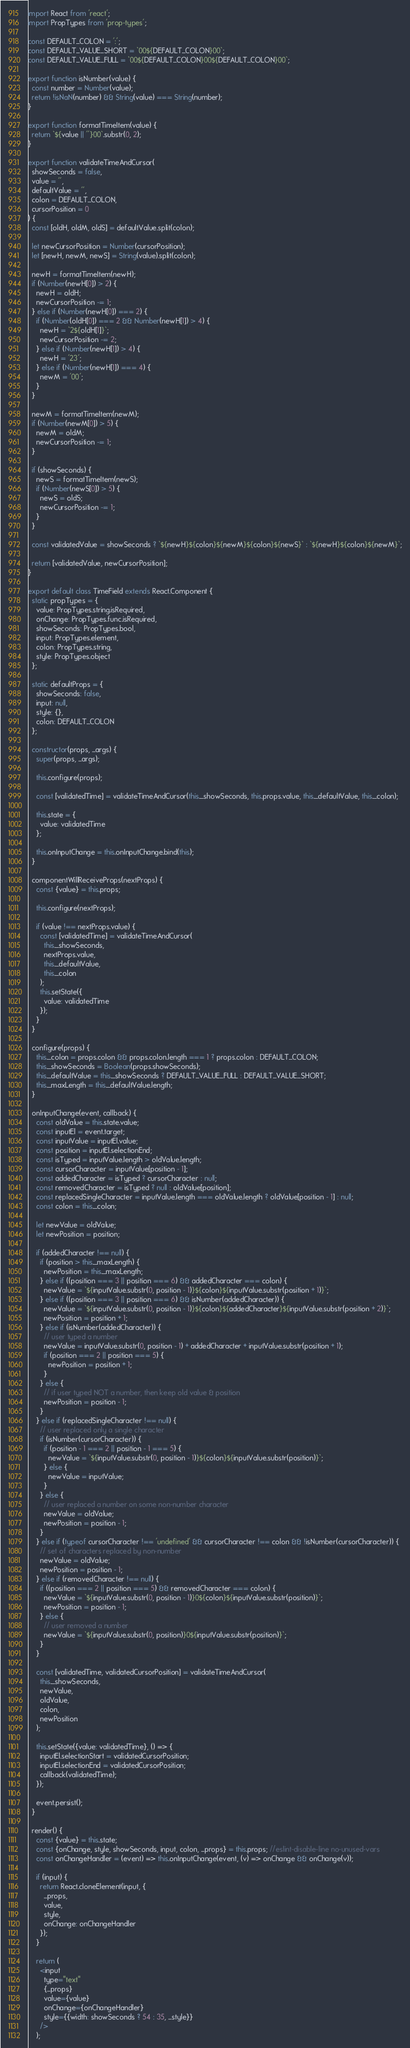Convert code to text. <code><loc_0><loc_0><loc_500><loc_500><_JavaScript_>import React from 'react';
import PropTypes from 'prop-types';

const DEFAULT_COLON = ':';
const DEFAULT_VALUE_SHORT = `00${DEFAULT_COLON}00`;
const DEFAULT_VALUE_FULL = `00${DEFAULT_COLON}00${DEFAULT_COLON}00`;

export function isNumber(value) {
  const number = Number(value);
  return !isNaN(number) && String(value) === String(number);
}

export function formatTimeItem(value) {
  return `${value || ''}00`.substr(0, 2);
}

export function validateTimeAndCursor(
  showSeconds = false,
  value = '',
  defaultValue = '',
  colon = DEFAULT_COLON,
  cursorPosition = 0
) {
  const [oldH, oldM, oldS] = defaultValue.split(colon);

  let newCursorPosition = Number(cursorPosition);
  let [newH, newM, newS] = String(value).split(colon);

  newH = formatTimeItem(newH);
  if (Number(newH[0]) > 2) {
    newH = oldH;
    newCursorPosition -= 1;
  } else if (Number(newH[0]) === 2) {
    if (Number(oldH[0]) === 2 && Number(newH[1]) > 4) {
      newH = `2${oldH[1]}`;
      newCursorPosition -= 2;
    } else if (Number(newH[1]) > 4) {
      newH = '23';
    } else if (Number(newH[1]) === 4) {
      newM = '00';
    }
  }

  newM = formatTimeItem(newM);
  if (Number(newM[0]) > 5) {
    newM = oldM;
    newCursorPosition -= 1;
  }

  if (showSeconds) {
    newS = formatTimeItem(newS);
    if (Number(newS[0]) > 5) {
      newS = oldS;
      newCursorPosition -= 1;
    }
  }

  const validatedValue = showSeconds ? `${newH}${colon}${newM}${colon}${newS}` : `${newH}${colon}${newM}`;

  return [validatedValue, newCursorPosition];
}

export default class TimeField extends React.Component {
  static propTypes = {
    value: PropTypes.string.isRequired,
    onChange: PropTypes.func.isRequired,
    showSeconds: PropTypes.bool,
    input: PropTypes.element,
    colon: PropTypes.string,
    style: PropTypes.object
  };

  static defaultProps = {
    showSeconds: false,
    input: null,
    style: {},
    colon: DEFAULT_COLON
  };

  constructor(props, ...args) {
    super(props, ...args);

    this.configure(props);

    const [validatedTime] = validateTimeAndCursor(this._showSeconds, this.props.value, this._defaultValue, this._colon);

    this.state = {
      value: validatedTime
    };

    this.onInputChange = this.onInputChange.bind(this);
  }

  componentWillReceiveProps(nextProps) {
    const {value} = this.props;

    this.configure(nextProps);

    if (value !== nextProps.value) {
      const [validatedTime] = validateTimeAndCursor(
        this._showSeconds,
        nextProps.value,
        this._defaultValue,
        this._colon
      );
      this.setState({
        value: validatedTime
      });
    }
  }

  configure(props) {
    this._colon = props.colon && props.colon.length === 1 ? props.colon : DEFAULT_COLON;
    this._showSeconds = Boolean(props.showSeconds);
    this._defaultValue = this._showSeconds ? DEFAULT_VALUE_FULL : DEFAULT_VALUE_SHORT;
    this._maxLength = this._defaultValue.length;
  }

  onInputChange(event, callback) {
    const oldValue = this.state.value;
    const inputEl = event.target;
    const inputValue = inputEl.value;
    const position = inputEl.selectionEnd;
    const isTyped = inputValue.length > oldValue.length;
    const cursorCharacter = inputValue[position - 1];
    const addedCharacter = isTyped ? cursorCharacter : null;
    const removedCharacter = isTyped ? null : oldValue[position];
    const replacedSingleCharacter = inputValue.length === oldValue.length ? oldValue[position - 1] : null;
    const colon = this._colon;

    let newValue = oldValue;
    let newPosition = position;

    if (addedCharacter !== null) {
      if (position > this._maxLength) {
        newPosition = this._maxLength;
      } else if ((position === 3 || position === 6) && addedCharacter === colon) {
        newValue = `${inputValue.substr(0, position - 1)}${colon}${inputValue.substr(position + 1)}`;
      } else if ((position === 3 || position === 6) && isNumber(addedCharacter)) {
        newValue = `${inputValue.substr(0, position - 1)}${colon}${addedCharacter}${inputValue.substr(position + 2)}`;
        newPosition = position + 1;
      } else if (isNumber(addedCharacter)) {
        // user typed a number
        newValue = inputValue.substr(0, position - 1) + addedCharacter + inputValue.substr(position + 1);
        if (position === 2 || position === 5) {
          newPosition = position + 1;
        }
      } else {
        // if user typed NOT a number, then keep old value & position
        newPosition = position - 1;
      }
    } else if (replacedSingleCharacter !== null) {
      // user replaced only a single character
      if (isNumber(cursorCharacter)) {
        if (position - 1 === 2 || position - 1 === 5) {
          newValue = `${inputValue.substr(0, position - 1)}${colon}${inputValue.substr(position)}`;
        } else {
          newValue = inputValue;
        }
      } else {
        // user replaced a number on some non-number character
        newValue = oldValue;
        newPosition = position - 1;
      }
    } else if (typeof cursorCharacter !== 'undefined' && cursorCharacter !== colon && !isNumber(cursorCharacter)) {
      // set of characters replaced by non-number
      newValue = oldValue;
      newPosition = position - 1;
    } else if (removedCharacter !== null) {
      if ((position === 2 || position === 5) && removedCharacter === colon) {
        newValue = `${inputValue.substr(0, position - 1)}0${colon}${inputValue.substr(position)}`;
        newPosition = position - 1;
      } else {
        // user removed a number
        newValue = `${inputValue.substr(0, position)}0${inputValue.substr(position)}`;
      }
    }

    const [validatedTime, validatedCursorPosition] = validateTimeAndCursor(
      this._showSeconds,
      newValue,
      oldValue,
      colon,
      newPosition
    );

    this.setState({value: validatedTime}, () => {
      inputEl.selectionStart = validatedCursorPosition;
      inputEl.selectionEnd = validatedCursorPosition;
      callback(validatedTime);
    });

    event.persist();
  }

  render() {
    const {value} = this.state;
    const {onChange, style, showSeconds, input, colon, ...props} = this.props; //eslint-disable-line no-unused-vars
    const onChangeHandler = (event) => this.onInputChange(event, (v) => onChange && onChange(v));

    if (input) {
      return React.cloneElement(input, {
        ...props,
        value,
        style,
        onChange: onChangeHandler
      });
    }

    return (
      <input
        type="text"
        {...props}
        value={value}
        onChange={onChangeHandler}
        style={{width: showSeconds ? 54 : 35, ...style}}
      />
    );</code> 